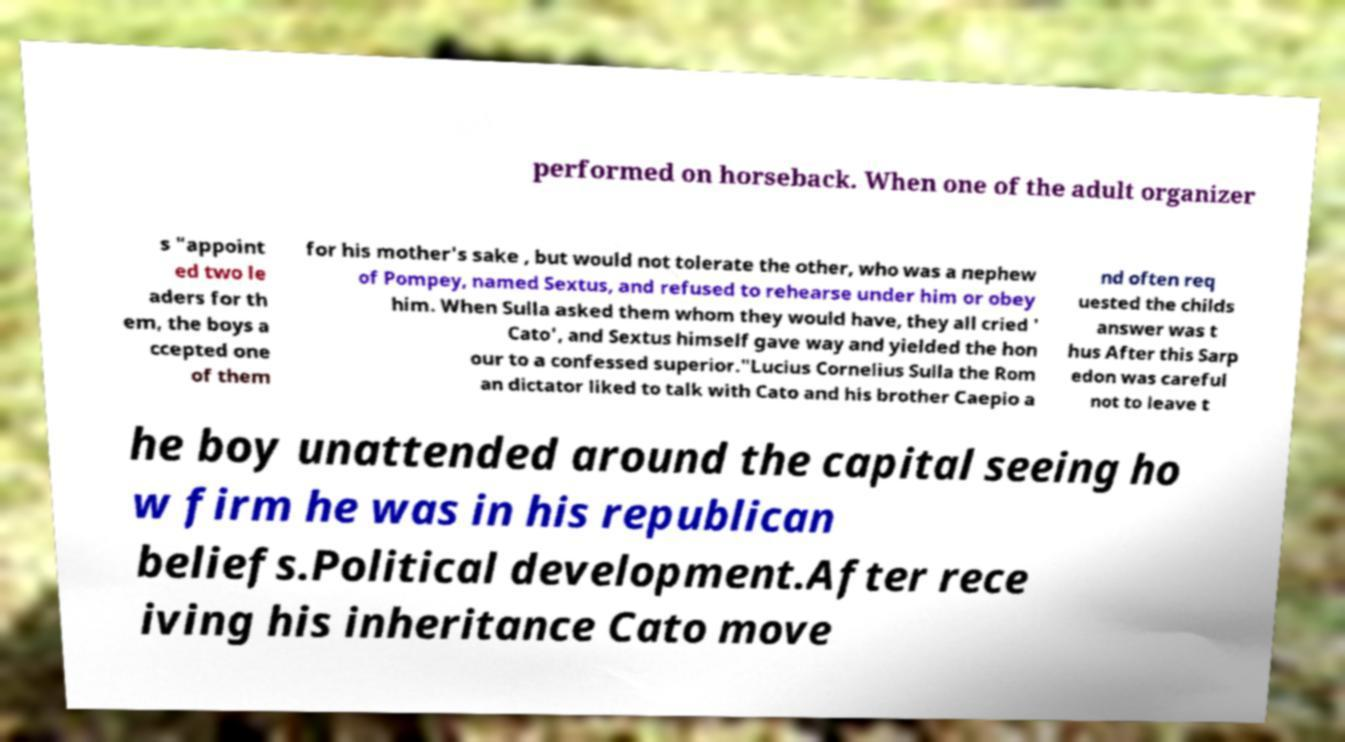There's text embedded in this image that I need extracted. Can you transcribe it verbatim? performed on horseback. When one of the adult organizer s "appoint ed two le aders for th em, the boys a ccepted one of them for his mother's sake , but would not tolerate the other, who was a nephew of Pompey, named Sextus, and refused to rehearse under him or obey him. When Sulla asked them whom they would have, they all cried ' Cato', and Sextus himself gave way and yielded the hon our to a confessed superior."Lucius Cornelius Sulla the Rom an dictator liked to talk with Cato and his brother Caepio a nd often req uested the childs answer was t hus After this Sarp edon was careful not to leave t he boy unattended around the capital seeing ho w firm he was in his republican beliefs.Political development.After rece iving his inheritance Cato move 